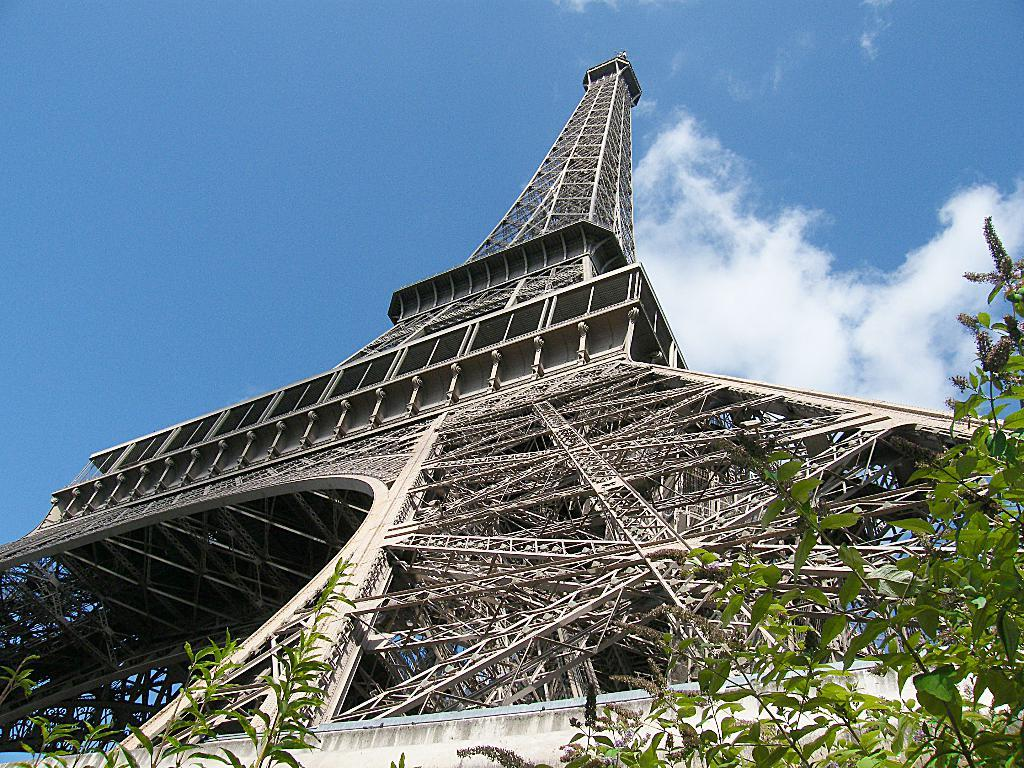What is the main structure in the picture? There is a tower in the picture. What type of vegetation is present in the picture? There is a tree and plants in the picture. How would you describe the sky in the picture? The sky is blue and cloudy in the picture. What type of breath can be seen coming from the tree in the picture? There is no breath visible in the picture, as trees do not breathe like animals. 